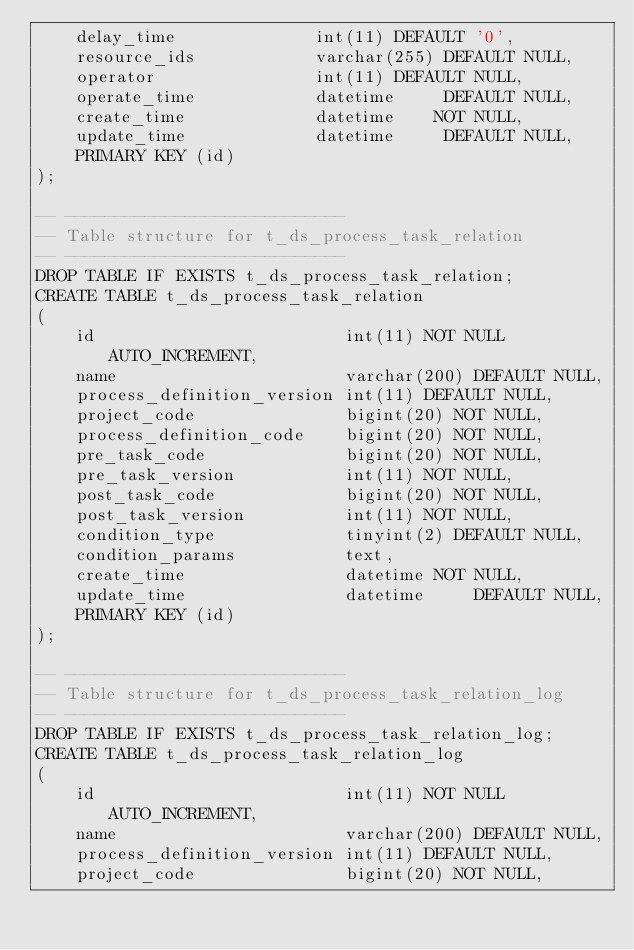<code> <loc_0><loc_0><loc_500><loc_500><_SQL_>    delay_time              int(11) DEFAULT '0',
    resource_ids            varchar(255) DEFAULT NULL,
    operator                int(11) DEFAULT NULL,
    operate_time            datetime     DEFAULT NULL,
    create_time             datetime    NOT NULL,
    update_time             datetime     DEFAULT NULL,
    PRIMARY KEY (id)
);

-- ----------------------------
-- Table structure for t_ds_process_task_relation
-- ----------------------------
DROP TABLE IF EXISTS t_ds_process_task_relation;
CREATE TABLE t_ds_process_task_relation
(
    id                         int(11) NOT NULL AUTO_INCREMENT,
    name                       varchar(200) DEFAULT NULL,
    process_definition_version int(11) DEFAULT NULL,
    project_code               bigint(20) NOT NULL,
    process_definition_code    bigint(20) NOT NULL,
    pre_task_code              bigint(20) NOT NULL,
    pre_task_version           int(11) NOT NULL,
    post_task_code             bigint(20) NOT NULL,
    post_task_version          int(11) NOT NULL,
    condition_type             tinyint(2) DEFAULT NULL,
    condition_params           text,
    create_time                datetime NOT NULL,
    update_time                datetime     DEFAULT NULL,
    PRIMARY KEY (id)
);

-- ----------------------------
-- Table structure for t_ds_process_task_relation_log
-- ----------------------------
DROP TABLE IF EXISTS t_ds_process_task_relation_log;
CREATE TABLE t_ds_process_task_relation_log
(
    id                         int(11) NOT NULL AUTO_INCREMENT,
    name                       varchar(200) DEFAULT NULL,
    process_definition_version int(11) DEFAULT NULL,
    project_code               bigint(20) NOT NULL,</code> 